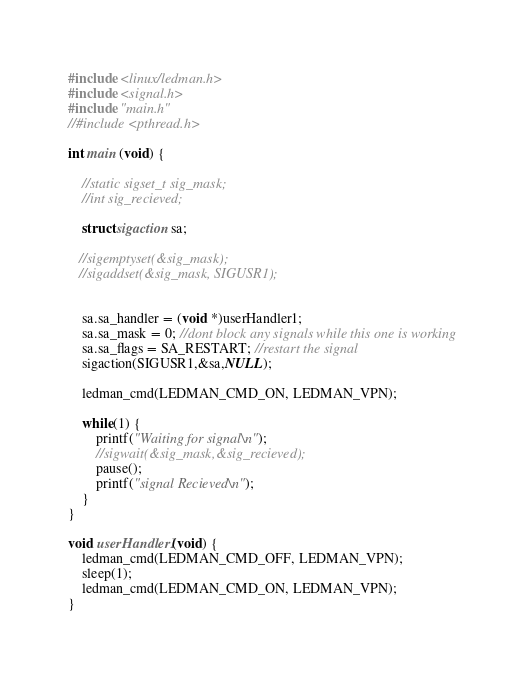<code> <loc_0><loc_0><loc_500><loc_500><_C_>
#include <linux/ledman.h>
#include <signal.h>
#include "main.h"
//#include <pthread.h>

int main (void) {
	
	//static sigset_t sig_mask;
	//int sig_recieved;
   
	struct sigaction sa;

   //sigemptyset(&sig_mask);
   //sigaddset(&sig_mask, SIGUSR1);


	sa.sa_handler = (void *)userHandler1;
	sa.sa_mask = 0; //dont block any signals while this one is working
	sa.sa_flags = SA_RESTART; //restart the signal
	sigaction(SIGUSR1,&sa,NULL);

	ledman_cmd(LEDMAN_CMD_ON, LEDMAN_VPN);
	
	while(1) {
		printf("Waiting for signal\n");
		//sigwait(&sig_mask,&sig_recieved);
		pause();
		printf("signal Recieved\n");
	}
}

void userHandler1(void) {
	ledman_cmd(LEDMAN_CMD_OFF, LEDMAN_VPN);
	sleep(1);
	ledman_cmd(LEDMAN_CMD_ON, LEDMAN_VPN);
}
</code> 